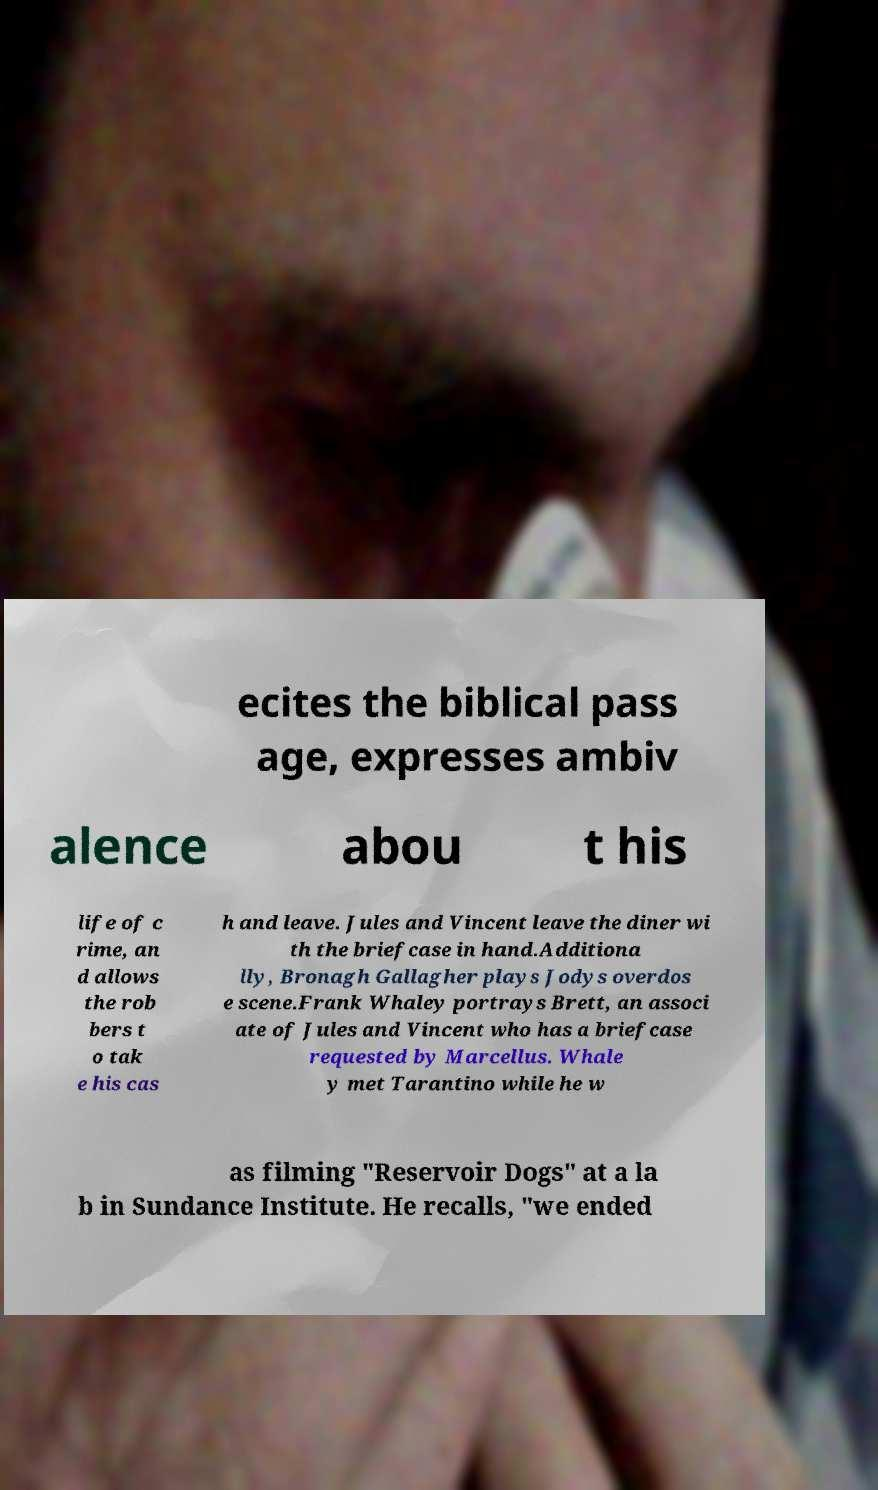Can you accurately transcribe the text from the provided image for me? ecites the biblical pass age, expresses ambiv alence abou t his life of c rime, an d allows the rob bers t o tak e his cas h and leave. Jules and Vincent leave the diner wi th the briefcase in hand.Additiona lly, Bronagh Gallagher plays Jodys overdos e scene.Frank Whaley portrays Brett, an associ ate of Jules and Vincent who has a briefcase requested by Marcellus. Whale y met Tarantino while he w as filming "Reservoir Dogs" at a la b in Sundance Institute. He recalls, "we ended 